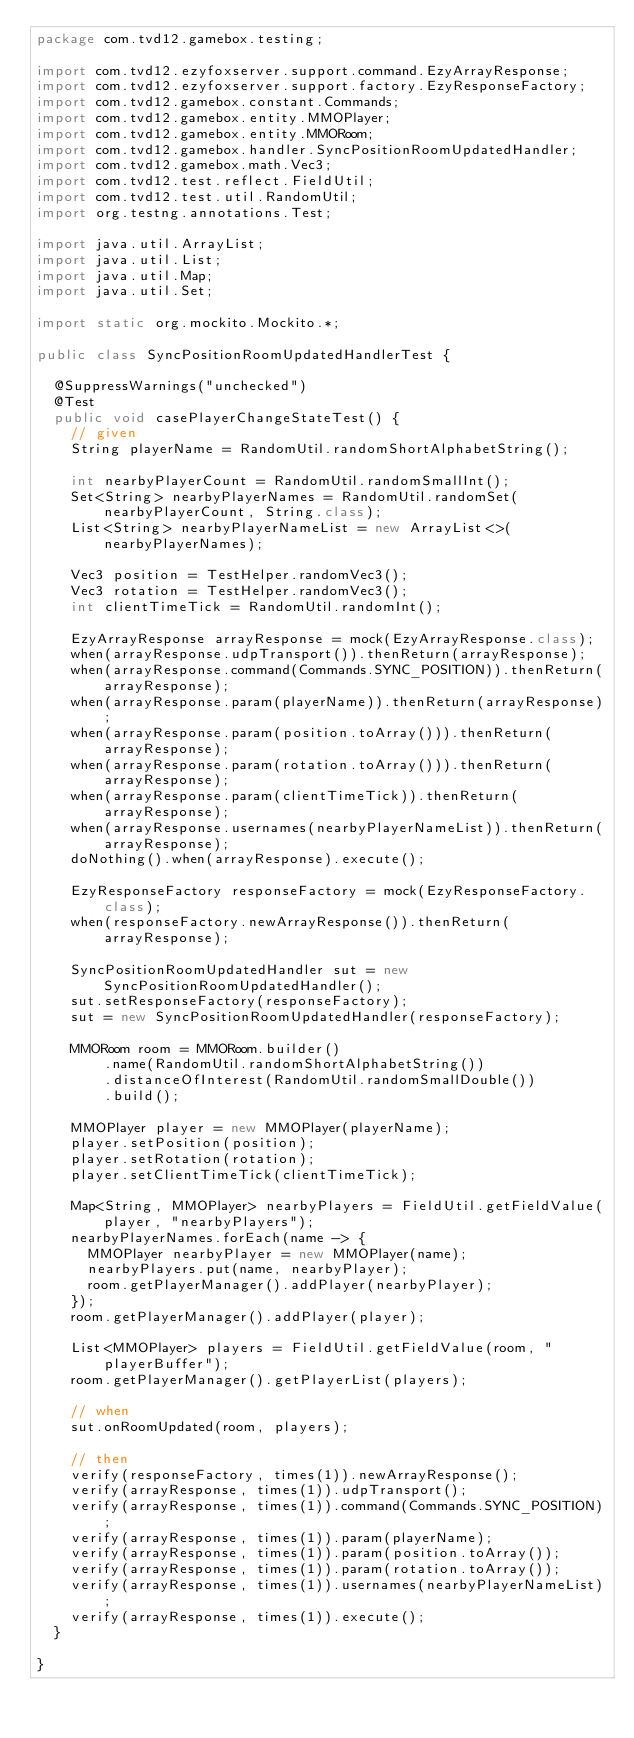<code> <loc_0><loc_0><loc_500><loc_500><_Java_>package com.tvd12.gamebox.testing;

import com.tvd12.ezyfoxserver.support.command.EzyArrayResponse;
import com.tvd12.ezyfoxserver.support.factory.EzyResponseFactory;
import com.tvd12.gamebox.constant.Commands;
import com.tvd12.gamebox.entity.MMOPlayer;
import com.tvd12.gamebox.entity.MMORoom;
import com.tvd12.gamebox.handler.SyncPositionRoomUpdatedHandler;
import com.tvd12.gamebox.math.Vec3;
import com.tvd12.test.reflect.FieldUtil;
import com.tvd12.test.util.RandomUtil;
import org.testng.annotations.Test;

import java.util.ArrayList;
import java.util.List;
import java.util.Map;
import java.util.Set;

import static org.mockito.Mockito.*;

public class SyncPositionRoomUpdatedHandlerTest {
	
	@SuppressWarnings("unchecked")
	@Test
	public void casePlayerChangeStateTest() {
		// given
		String playerName = RandomUtil.randomShortAlphabetString();
		
		int nearbyPlayerCount = RandomUtil.randomSmallInt();
		Set<String> nearbyPlayerNames = RandomUtil.randomSet(nearbyPlayerCount, String.class);
		List<String> nearbyPlayerNameList = new ArrayList<>(nearbyPlayerNames);
		
		Vec3 position = TestHelper.randomVec3();
		Vec3 rotation = TestHelper.randomVec3();
		int clientTimeTick = RandomUtil.randomInt();
		
		EzyArrayResponse arrayResponse = mock(EzyArrayResponse.class);
		when(arrayResponse.udpTransport()).thenReturn(arrayResponse);
		when(arrayResponse.command(Commands.SYNC_POSITION)).thenReturn(arrayResponse);
		when(arrayResponse.param(playerName)).thenReturn(arrayResponse);
		when(arrayResponse.param(position.toArray())).thenReturn(arrayResponse);
		when(arrayResponse.param(rotation.toArray())).thenReturn(arrayResponse);
		when(arrayResponse.param(clientTimeTick)).thenReturn(arrayResponse);
		when(arrayResponse.usernames(nearbyPlayerNameList)).thenReturn(arrayResponse);
		doNothing().when(arrayResponse).execute();
		
		EzyResponseFactory responseFactory = mock(EzyResponseFactory.class);
		when(responseFactory.newArrayResponse()).thenReturn(arrayResponse);
		
		SyncPositionRoomUpdatedHandler sut = new SyncPositionRoomUpdatedHandler();
		sut.setResponseFactory(responseFactory);
		sut = new SyncPositionRoomUpdatedHandler(responseFactory);
		
		MMORoom room = MMORoom.builder()
				.name(RandomUtil.randomShortAlphabetString())
				.distanceOfInterest(RandomUtil.randomSmallDouble())
				.build();
		
		MMOPlayer player = new MMOPlayer(playerName);
		player.setPosition(position);
		player.setRotation(rotation);
		player.setClientTimeTick(clientTimeTick);
		
		Map<String, MMOPlayer> nearbyPlayers = FieldUtil.getFieldValue(player, "nearbyPlayers");
		nearbyPlayerNames.forEach(name -> {
			MMOPlayer nearbyPlayer = new MMOPlayer(name);
			nearbyPlayers.put(name, nearbyPlayer);
			room.getPlayerManager().addPlayer(nearbyPlayer);
		});
		room.getPlayerManager().addPlayer(player);
		
		List<MMOPlayer> players = FieldUtil.getFieldValue(room, "playerBuffer");
		room.getPlayerManager().getPlayerList(players);
		
		// when
		sut.onRoomUpdated(room, players);
		
		// then
		verify(responseFactory, times(1)).newArrayResponse();
		verify(arrayResponse, times(1)).udpTransport();
		verify(arrayResponse, times(1)).command(Commands.SYNC_POSITION);
		verify(arrayResponse, times(1)).param(playerName);
		verify(arrayResponse, times(1)).param(position.toArray());
		verify(arrayResponse, times(1)).param(rotation.toArray());
		verify(arrayResponse, times(1)).usernames(nearbyPlayerNameList);
		verify(arrayResponse, times(1)).execute();
	}
	
}
</code> 